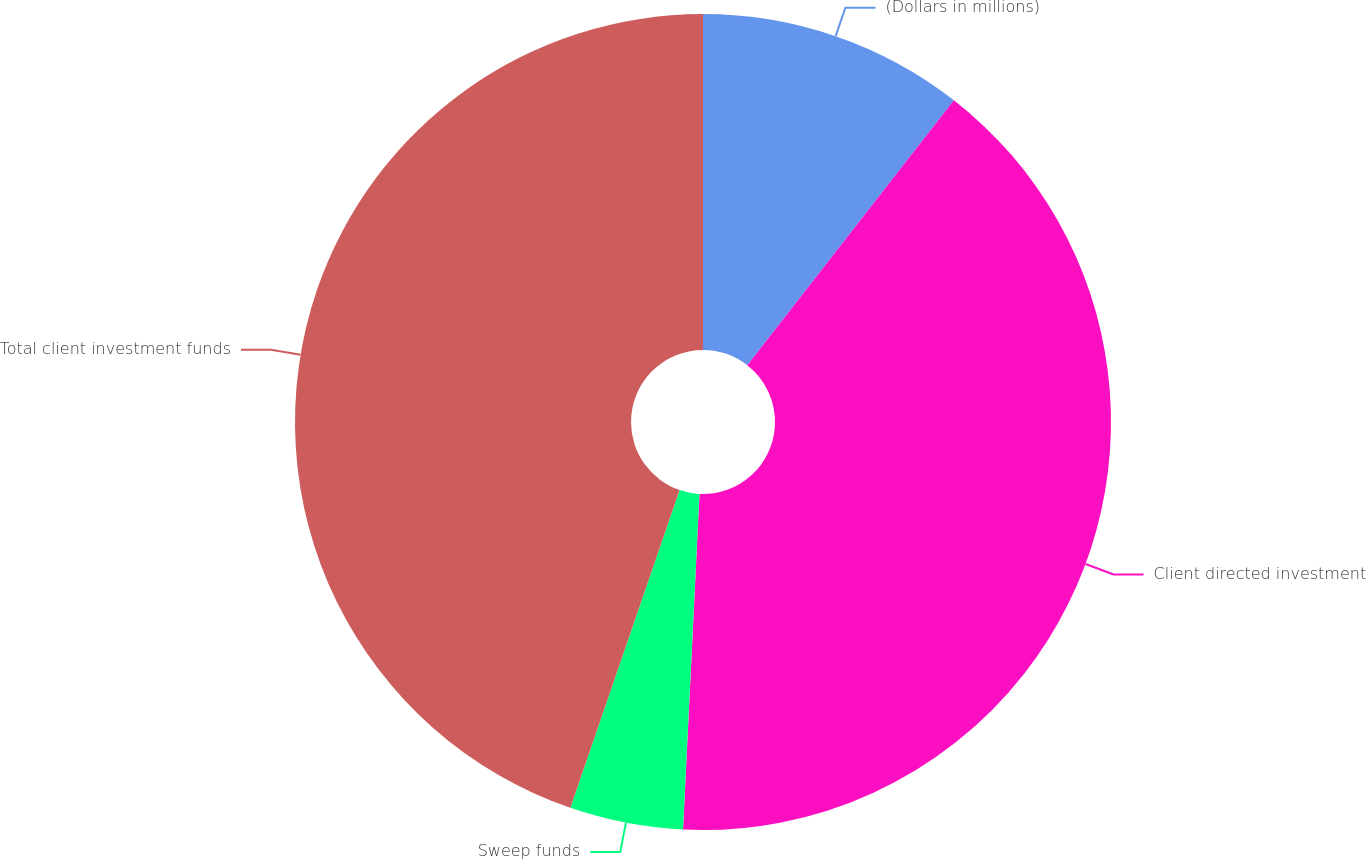Convert chart. <chart><loc_0><loc_0><loc_500><loc_500><pie_chart><fcel>(Dollars in millions)<fcel>Client directed investment<fcel>Sweep funds<fcel>Total client investment funds<nl><fcel>10.54%<fcel>40.24%<fcel>4.49%<fcel>44.73%<nl></chart> 